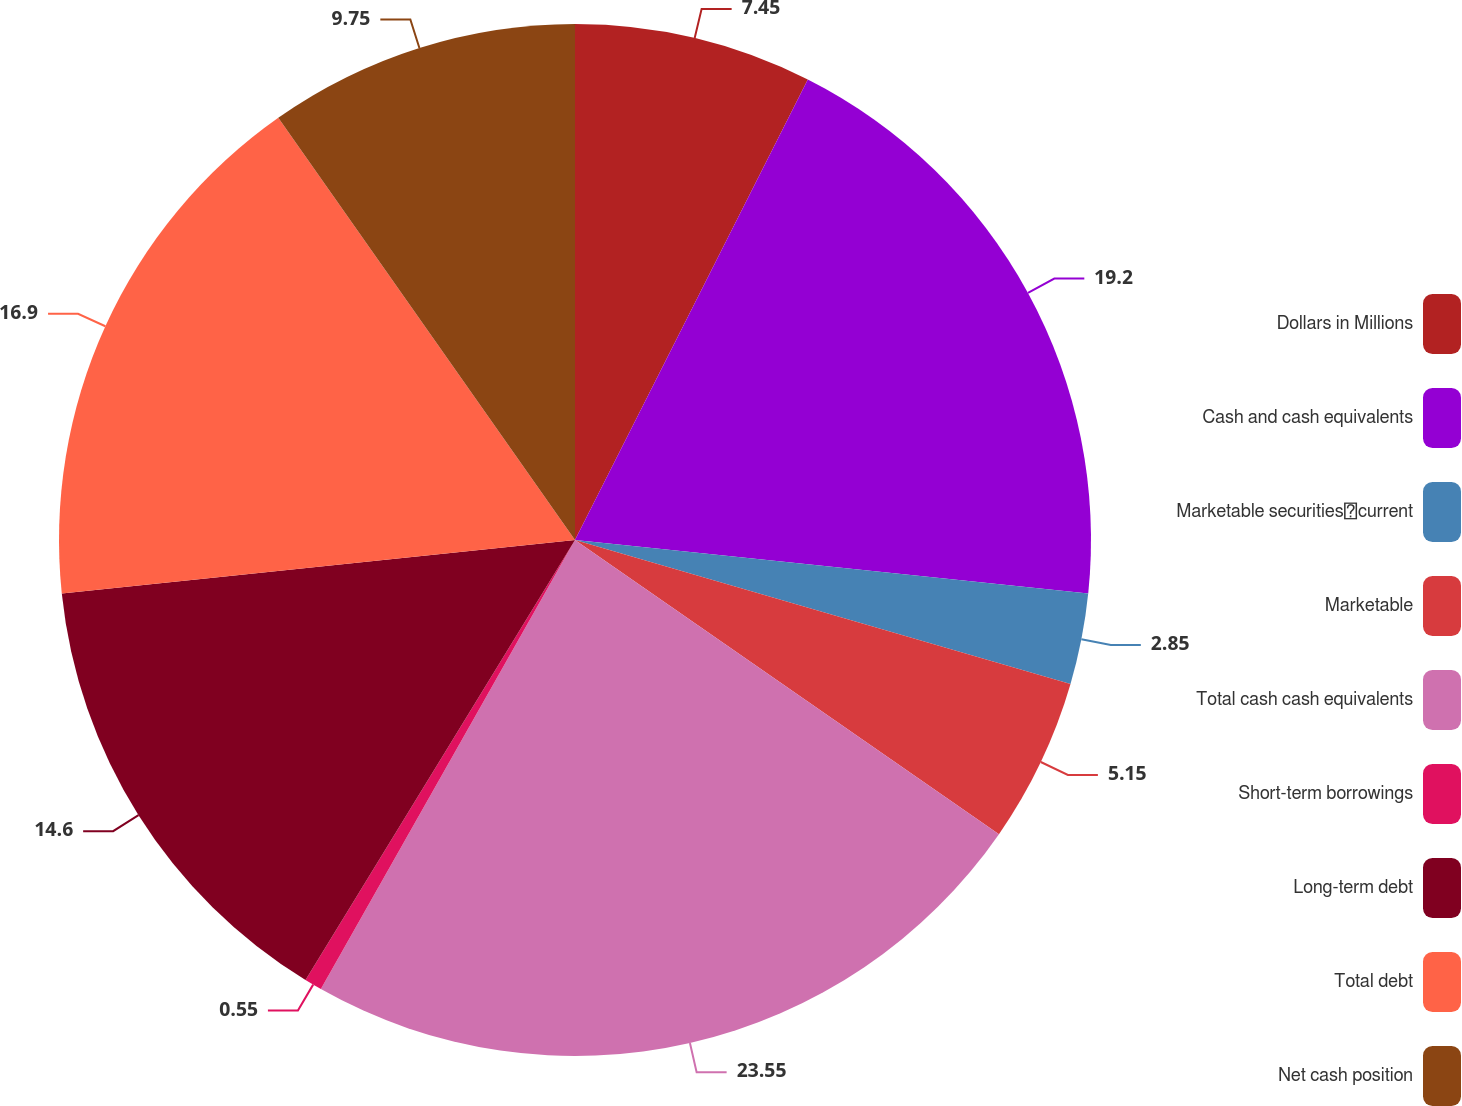Convert chart. <chart><loc_0><loc_0><loc_500><loc_500><pie_chart><fcel>Dollars in Millions<fcel>Cash and cash equivalents<fcel>Marketable securitiescurrent<fcel>Marketable<fcel>Total cash cash equivalents<fcel>Short-term borrowings<fcel>Long-term debt<fcel>Total debt<fcel>Net cash position<nl><fcel>7.45%<fcel>19.2%<fcel>2.85%<fcel>5.15%<fcel>23.54%<fcel>0.55%<fcel>14.6%<fcel>16.9%<fcel>9.75%<nl></chart> 